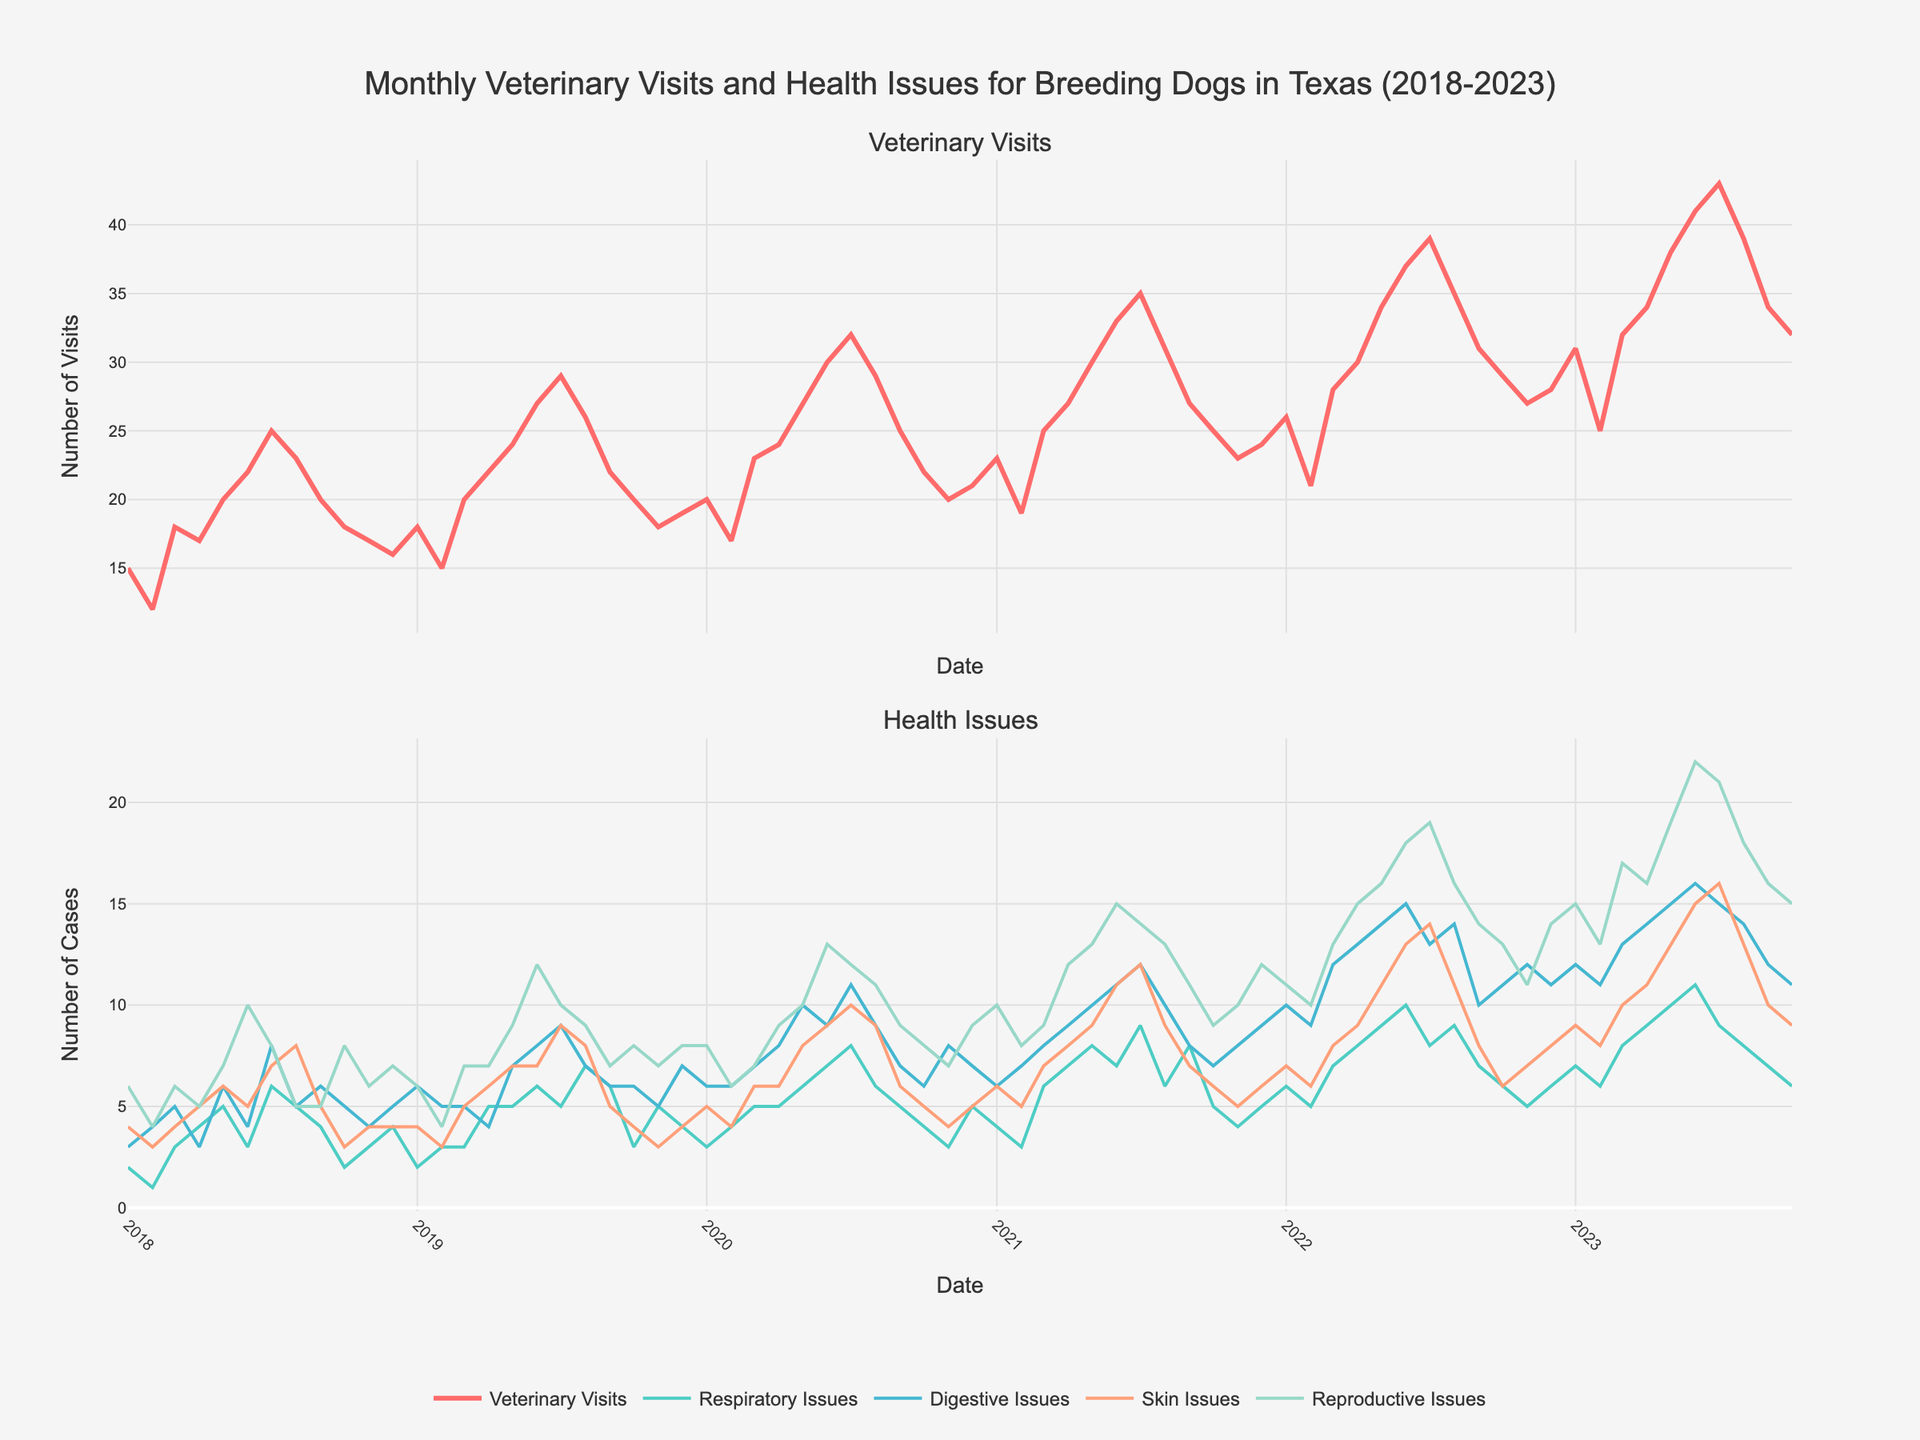How many veterinary visits were recorded in July 2021? Locate July 2021 on the x-axis, then refer to the y-axis value under "Veterinary Visits" in the first subplot.
Answer: 35 What's the average number of reproductive issues reported in the last 6 months of 2020? Identify the last 6 months of 2020, then sum their reproductive issues and divide by 6: (8 + 7 + 9 + 9 + 11 + 9) / 6 = 53 / 6.
Answer: 8.83 Which month and year had the highest number of veterinary visits? Observe the peaks in the "Veterinary Visits" subplot and identify the highest point and its corresponding month and year.
Answer: July 2023 Compare the number of digestive issues reported in May 2023 vs May 2022. Which month had more cases? Locate May for both 2022 and 2023 on the x-axis, then compare their values for digestive issues.
Answer: May 2023 In which year was there a consistent increase in veterinary visits over the months? Identify the subplot for veterinary visits and look for the year where the trend generally increases each subsequent month.
Answer: 2023 What is the trend of skin issues from January 2019 to July 2019? Trace the line for skin issues between January and July 2019 and describe the changes in the line.
Answer: Increasing How many more reproductive issues were there in June 2023 compared to June 2020? Find June in both 2020 and 2023 and subtract the number of reproductive issues of June 2020 from June 2023. (22 - 13) = 9
Answer: 9 Compare the number of respiratory issues in April 2020 and April 2021. How do they differ? Locate April 2020 and April 2021 for respiratory issues and subtract one from the other (7 - 5) = 2.
Answer: 2 What's the overall trend of veterinary visits over the 5 years? Analyze the "Veterinary Visits" subplot over the entire time span and describe the general direction or pattern of the series.
Answer: Increasing In which month of any year did digestive issues peak? Locate the highest point in the "Digestive Issues" line across the entire timeline and identify the month and year related to that peak.
Answer: June 2023 